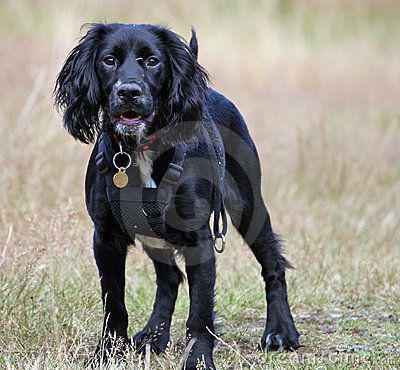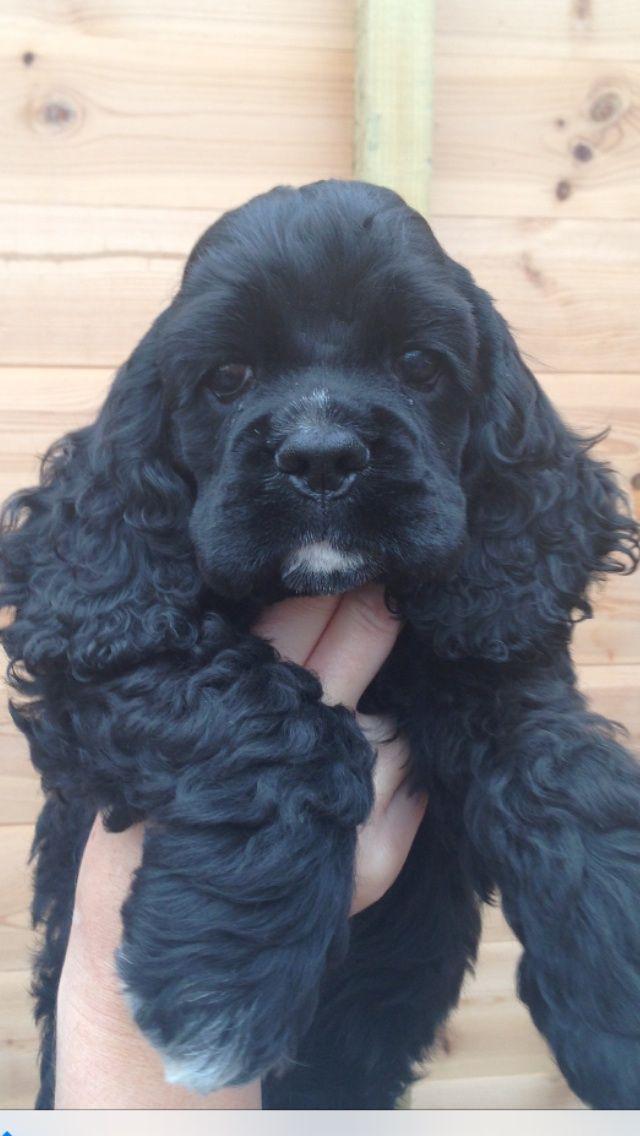The first image is the image on the left, the second image is the image on the right. For the images shown, is this caption "One dark puppy is standing, and the other dark puppy is reclining." true? Answer yes or no. No. The first image is the image on the left, the second image is the image on the right. Evaluate the accuracy of this statement regarding the images: "A single dog is posed on grass in the left image.". Is it true? Answer yes or no. Yes. 